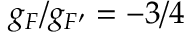<formula> <loc_0><loc_0><loc_500><loc_500>g _ { F } / g _ { F ^ { \prime } } = - 3 / 4</formula> 